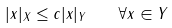<formula> <loc_0><loc_0><loc_500><loc_500>| x | _ { X } \leq c | x | _ { Y } \quad \forall x \in Y</formula> 